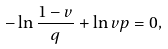<formula> <loc_0><loc_0><loc_500><loc_500>- \ln \frac { 1 - v } { q } + \ln { v } { p } = 0 ,</formula> 